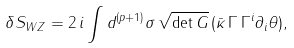<formula> <loc_0><loc_0><loc_500><loc_500>\delta S _ { W Z } = 2 \, i \int d ^ { ( p + 1 ) } \sigma \, \sqrt { \det G } \, ( \bar { \kappa } \, \Gamma \, \Gamma ^ { i } \partial _ { i } \theta ) ,</formula> 